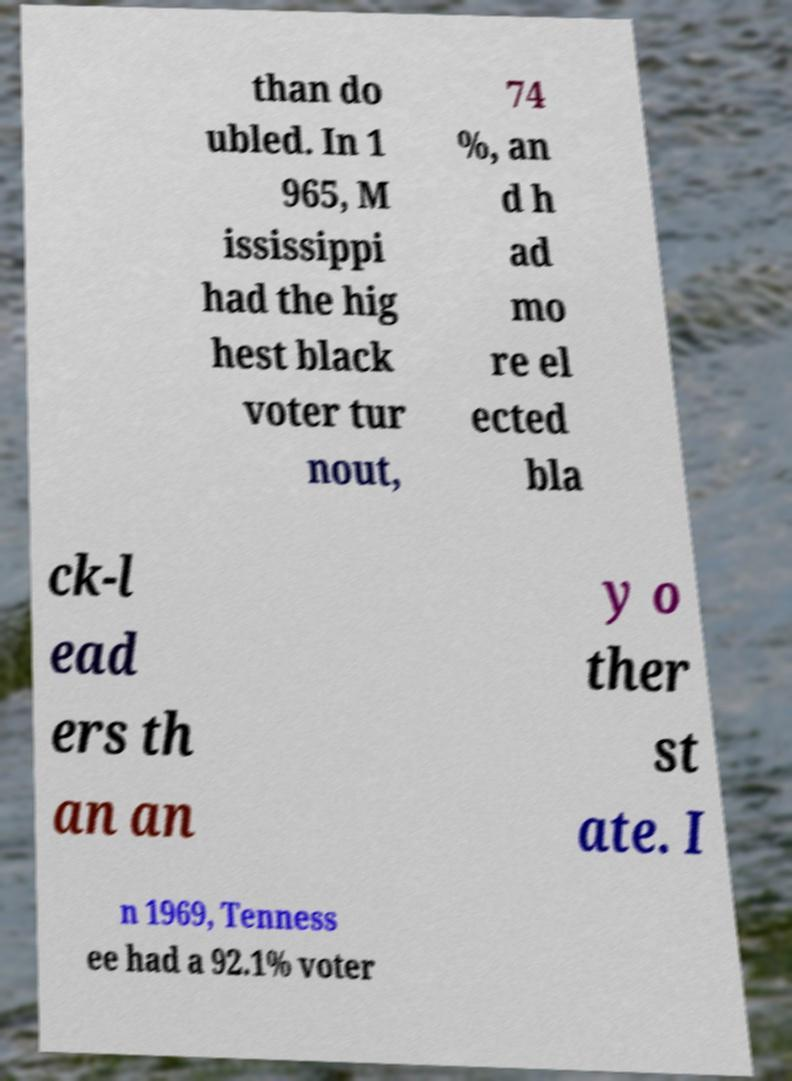There's text embedded in this image that I need extracted. Can you transcribe it verbatim? than do ubled. In 1 965, M ississippi had the hig hest black voter tur nout, 74 %, an d h ad mo re el ected bla ck-l ead ers th an an y o ther st ate. I n 1969, Tenness ee had a 92.1% voter 